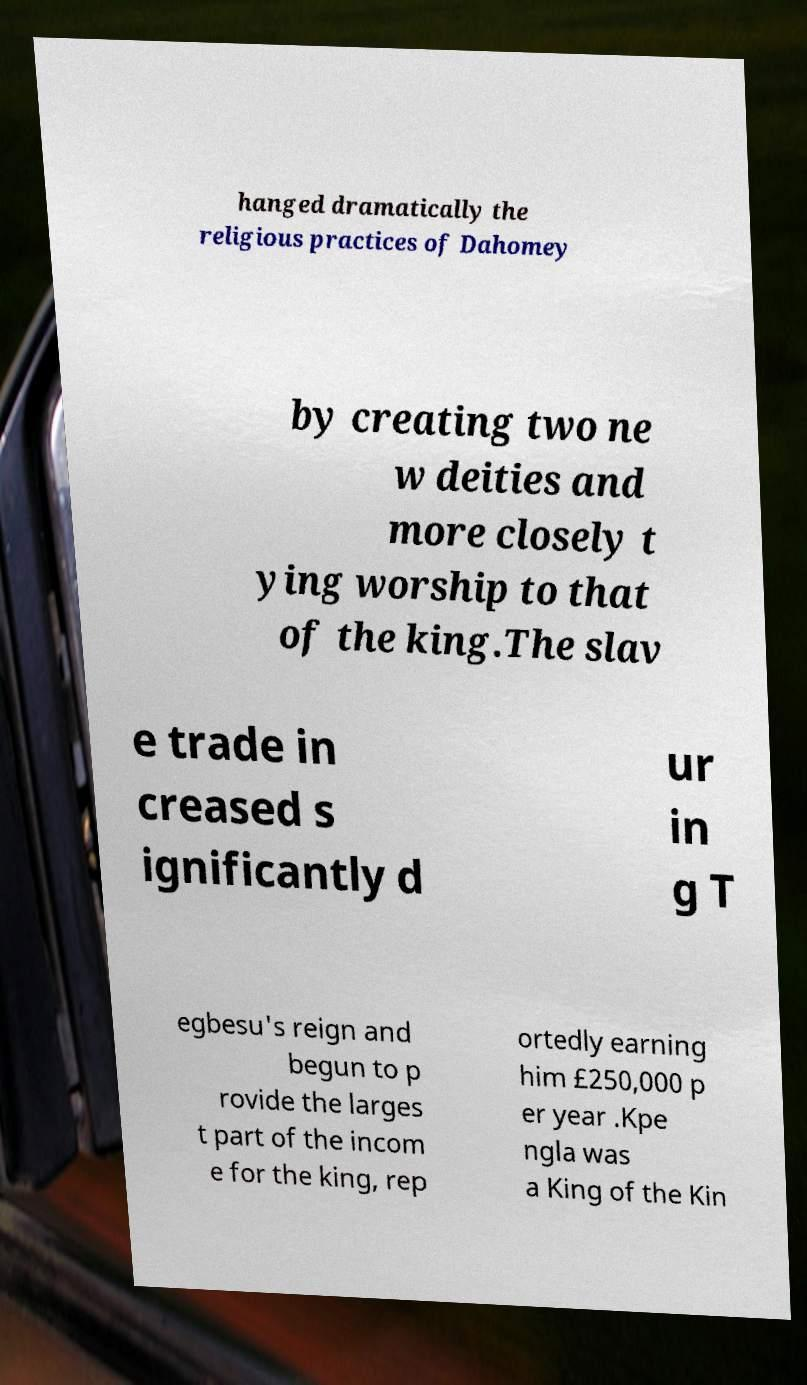Can you accurately transcribe the text from the provided image for me? hanged dramatically the religious practices of Dahomey by creating two ne w deities and more closely t ying worship to that of the king.The slav e trade in creased s ignificantly d ur in g T egbesu's reign and begun to p rovide the larges t part of the incom e for the king, rep ortedly earning him £250,000 p er year .Kpe ngla was a King of the Kin 